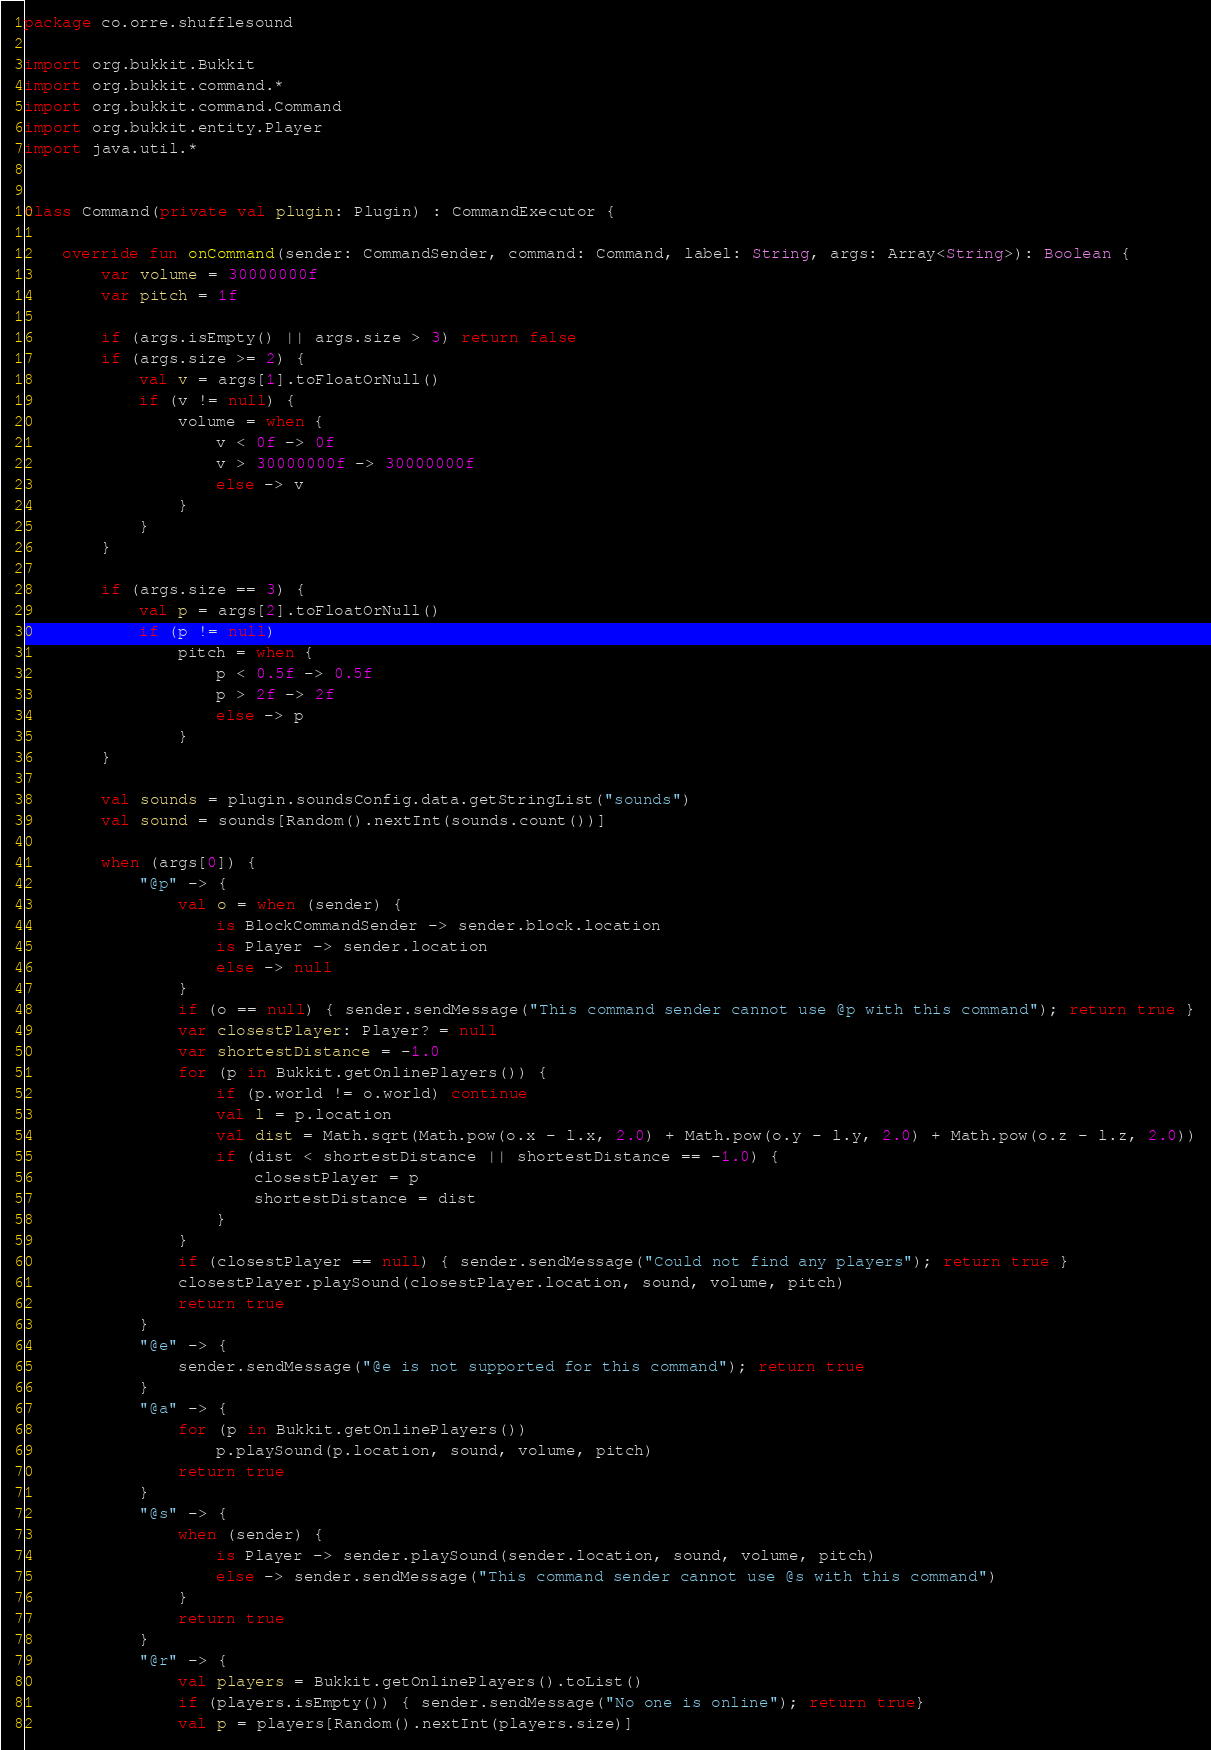<code> <loc_0><loc_0><loc_500><loc_500><_Kotlin_>package co.orre.shufflesound

import org.bukkit.Bukkit
import org.bukkit.command.*
import org.bukkit.command.Command
import org.bukkit.entity.Player
import java.util.*


class Command(private val plugin: Plugin) : CommandExecutor {

    override fun onCommand(sender: CommandSender, command: Command, label: String, args: Array<String>): Boolean {
        var volume = 30000000f
        var pitch = 1f

        if (args.isEmpty() || args.size > 3) return false
        if (args.size >= 2) {
            val v = args[1].toFloatOrNull()
            if (v != null) {
                volume = when {
                    v < 0f -> 0f
                    v > 30000000f -> 30000000f
                    else -> v
                }
            }
        }

        if (args.size == 3) {
            val p = args[2].toFloatOrNull()
            if (p != null)
                pitch = when {
                    p < 0.5f -> 0.5f
                    p > 2f -> 2f
                    else -> p
                }
        }

        val sounds = plugin.soundsConfig.data.getStringList("sounds")
        val sound = sounds[Random().nextInt(sounds.count())]

        when (args[0]) {
            "@p" -> {
                val o = when (sender) {
                    is BlockCommandSender -> sender.block.location
                    is Player -> sender.location
                    else -> null
                }
                if (o == null) { sender.sendMessage("This command sender cannot use @p with this command"); return true }
                var closestPlayer: Player? = null
                var shortestDistance = -1.0
                for (p in Bukkit.getOnlinePlayers()) {
                    if (p.world != o.world) continue
                    val l = p.location
                    val dist = Math.sqrt(Math.pow(o.x - l.x, 2.0) + Math.pow(o.y - l.y, 2.0) + Math.pow(o.z - l.z, 2.0))
                    if (dist < shortestDistance || shortestDistance == -1.0) {
                        closestPlayer = p
                        shortestDistance = dist
                    }
                }
                if (closestPlayer == null) { sender.sendMessage("Could not find any players"); return true }
                closestPlayer.playSound(closestPlayer.location, sound, volume, pitch)
                return true
            }
            "@e" -> {
                sender.sendMessage("@e is not supported for this command"); return true
            }
            "@a" -> {
                for (p in Bukkit.getOnlinePlayers())
                    p.playSound(p.location, sound, volume, pitch)
                return true
            }
            "@s" -> {
                when (sender) {
                    is Player -> sender.playSound(sender.location, sound, volume, pitch)
                    else -> sender.sendMessage("This command sender cannot use @s with this command")
                }
                return true
            }
            "@r" -> {
                val players = Bukkit.getOnlinePlayers().toList()
                if (players.isEmpty()) { sender.sendMessage("No one is online"); return true}
                val p = players[Random().nextInt(players.size)]</code> 